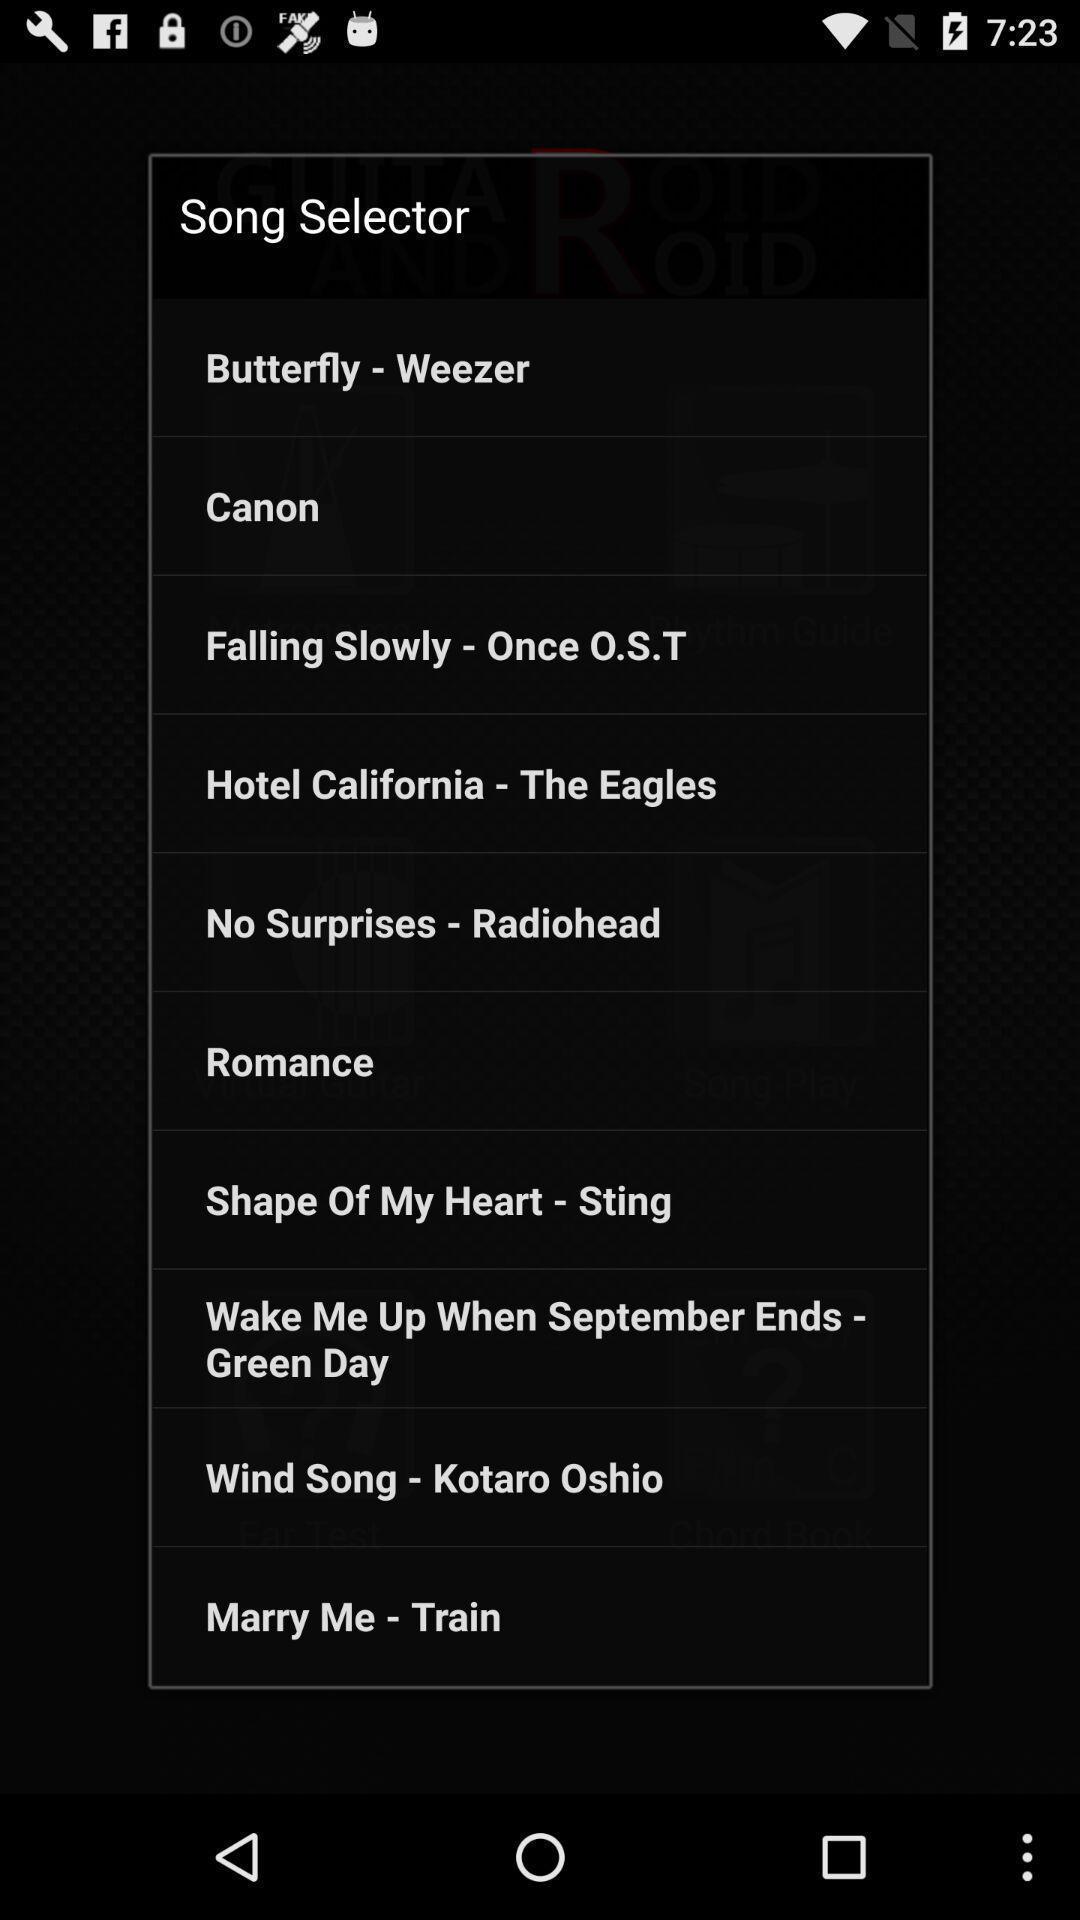Describe the content in this image. Pop up displaying the multiple options songs. 